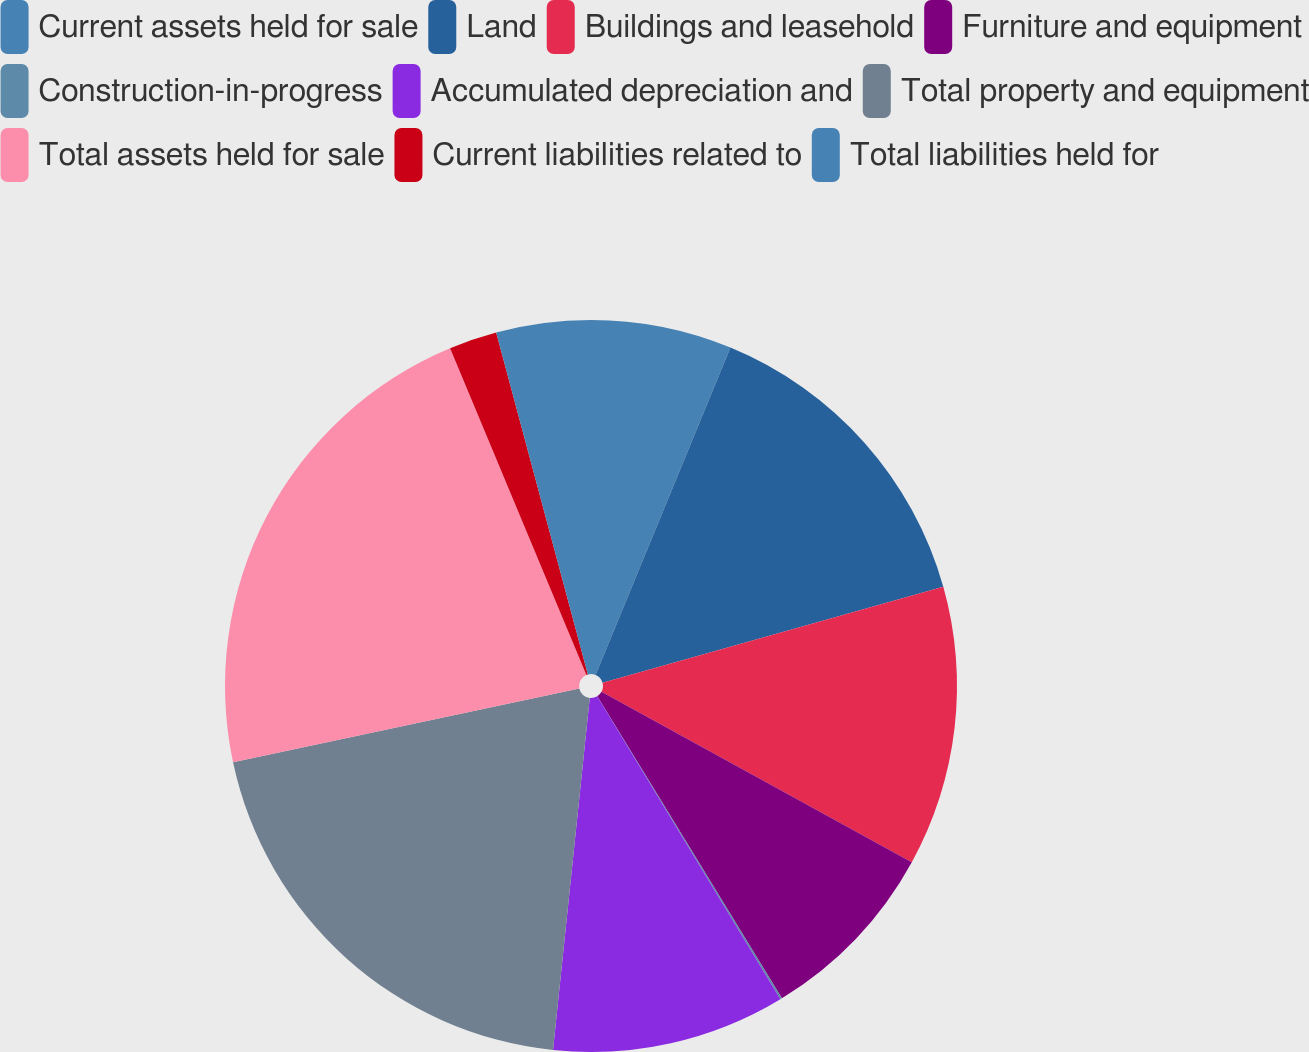Convert chart. <chart><loc_0><loc_0><loc_500><loc_500><pie_chart><fcel>Current assets held for sale<fcel>Land<fcel>Buildings and leasehold<fcel>Furniture and equipment<fcel>Construction-in-progress<fcel>Accumulated depreciation and<fcel>Total property and equipment<fcel>Total assets held for sale<fcel>Current liabilities related to<fcel>Total liabilities held for<nl><fcel>6.22%<fcel>14.41%<fcel>12.36%<fcel>8.27%<fcel>0.08%<fcel>10.31%<fcel>20.0%<fcel>22.05%<fcel>2.12%<fcel>4.17%<nl></chart> 